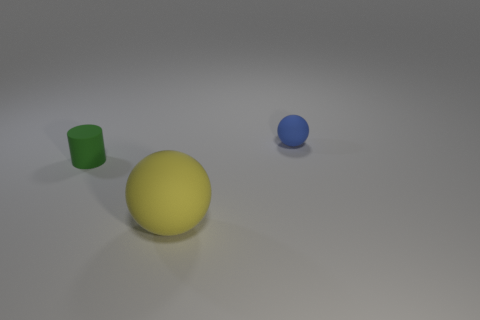Add 2 large yellow spheres. How many objects exist? 5 Subtract all cylinders. How many objects are left? 2 Subtract all small rubber spheres. Subtract all tiny blue spheres. How many objects are left? 1 Add 3 green cylinders. How many green cylinders are left? 4 Add 2 large red shiny things. How many large red shiny things exist? 2 Subtract 0 gray spheres. How many objects are left? 3 